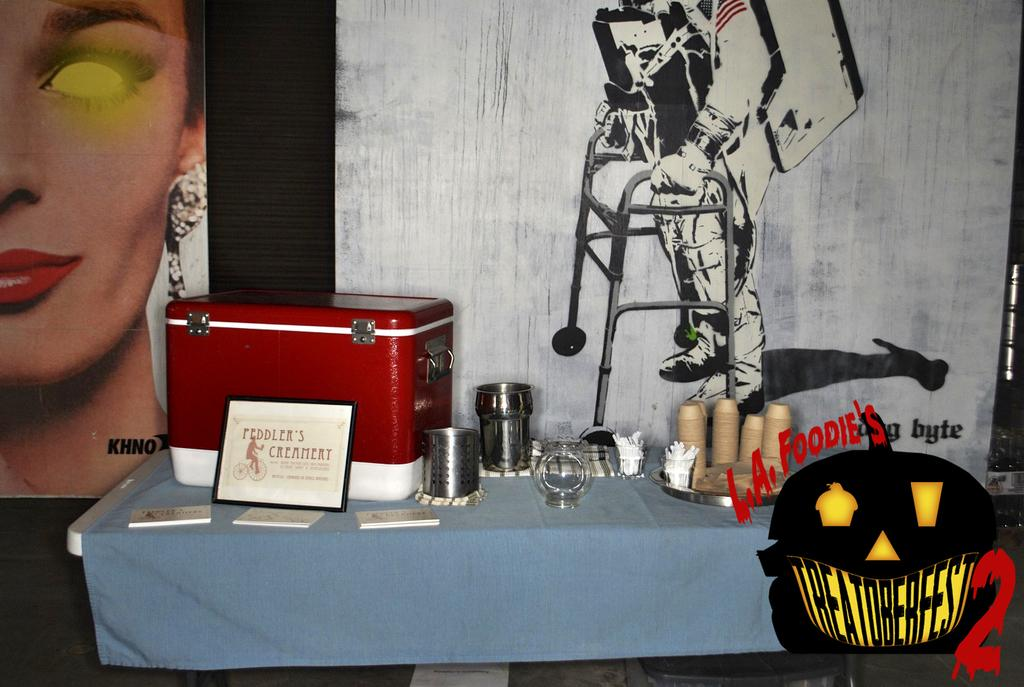<image>
Offer a succinct explanation of the picture presented. a display from Feddler's Creamery in front of a disabled astronaut poster 